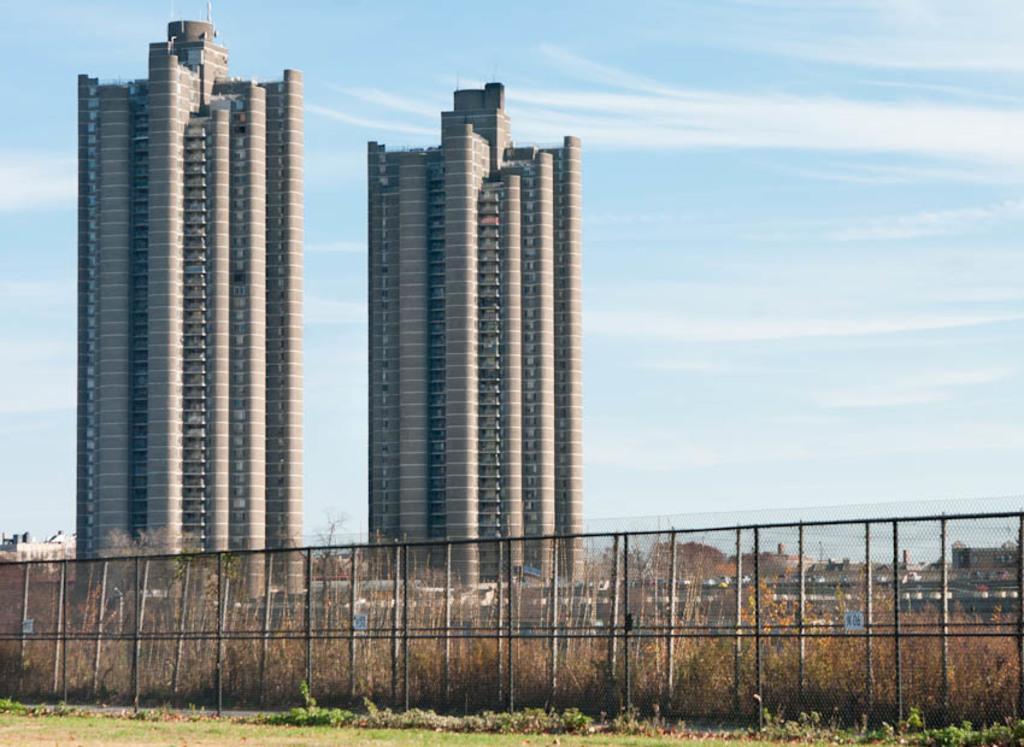How would you summarize this image in a sentence or two? In this image I can see few buildings, fencing, dry grass and the sky is in blue and white. 